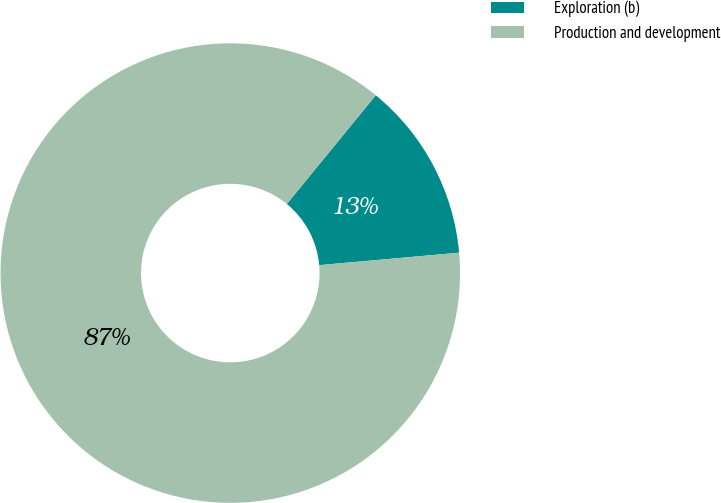Convert chart. <chart><loc_0><loc_0><loc_500><loc_500><pie_chart><fcel>Exploration (b)<fcel>Production and development<nl><fcel>12.67%<fcel>87.33%<nl></chart> 